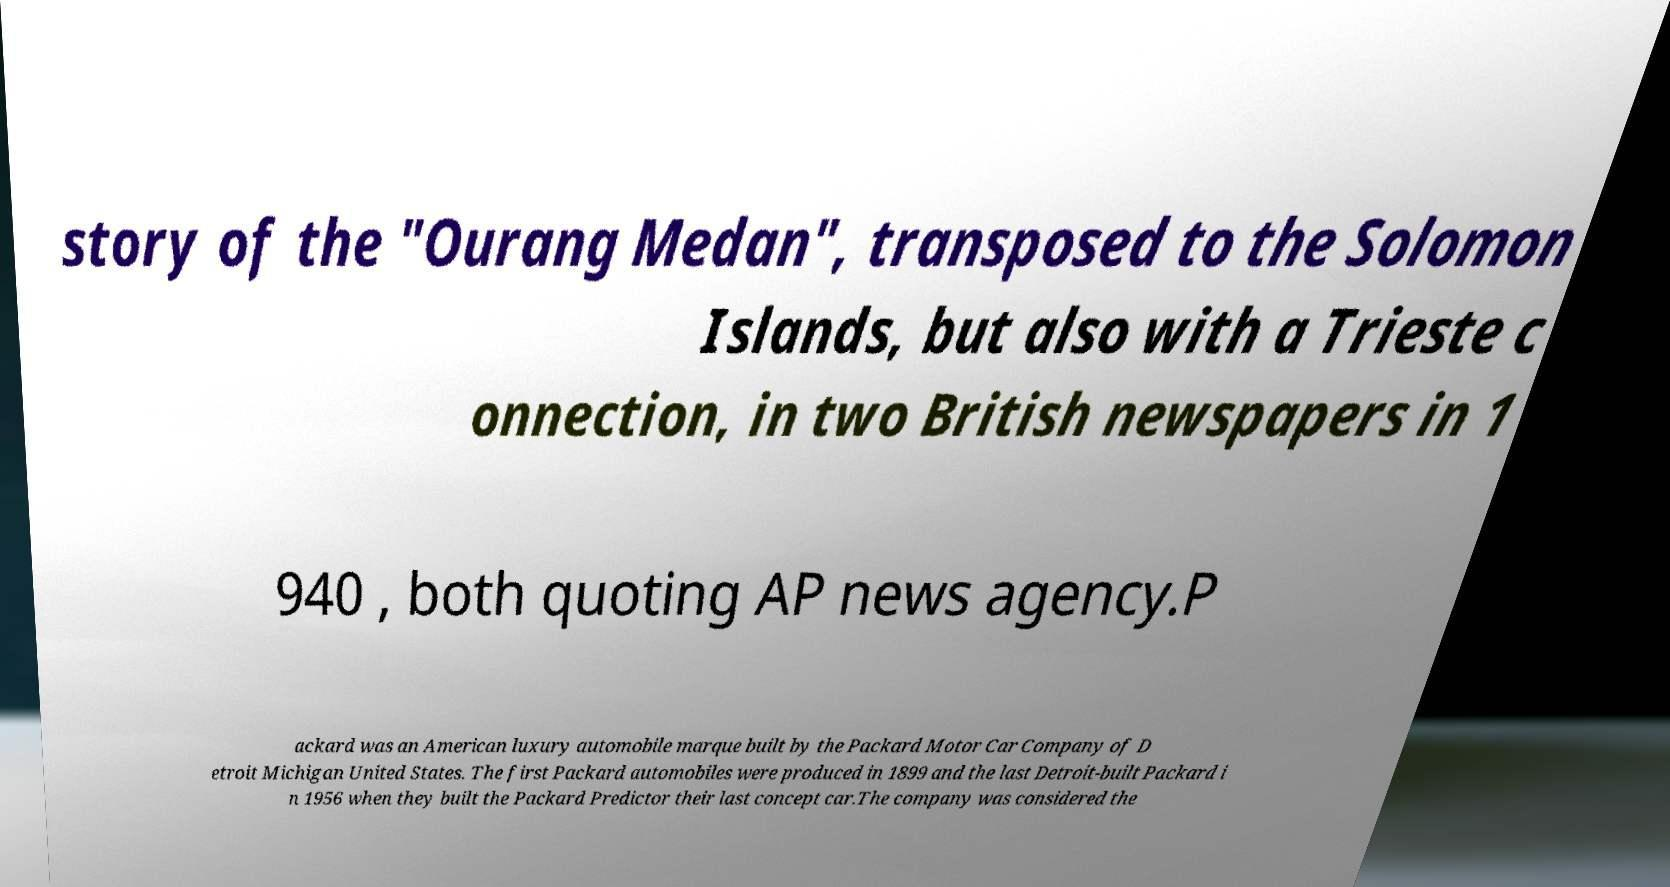Please read and relay the text visible in this image. What does it say? story of the "Ourang Medan", transposed to the Solomon Islands, but also with a Trieste c onnection, in two British newspapers in 1 940 , both quoting AP news agency.P ackard was an American luxury automobile marque built by the Packard Motor Car Company of D etroit Michigan United States. The first Packard automobiles were produced in 1899 and the last Detroit-built Packard i n 1956 when they built the Packard Predictor their last concept car.The company was considered the 